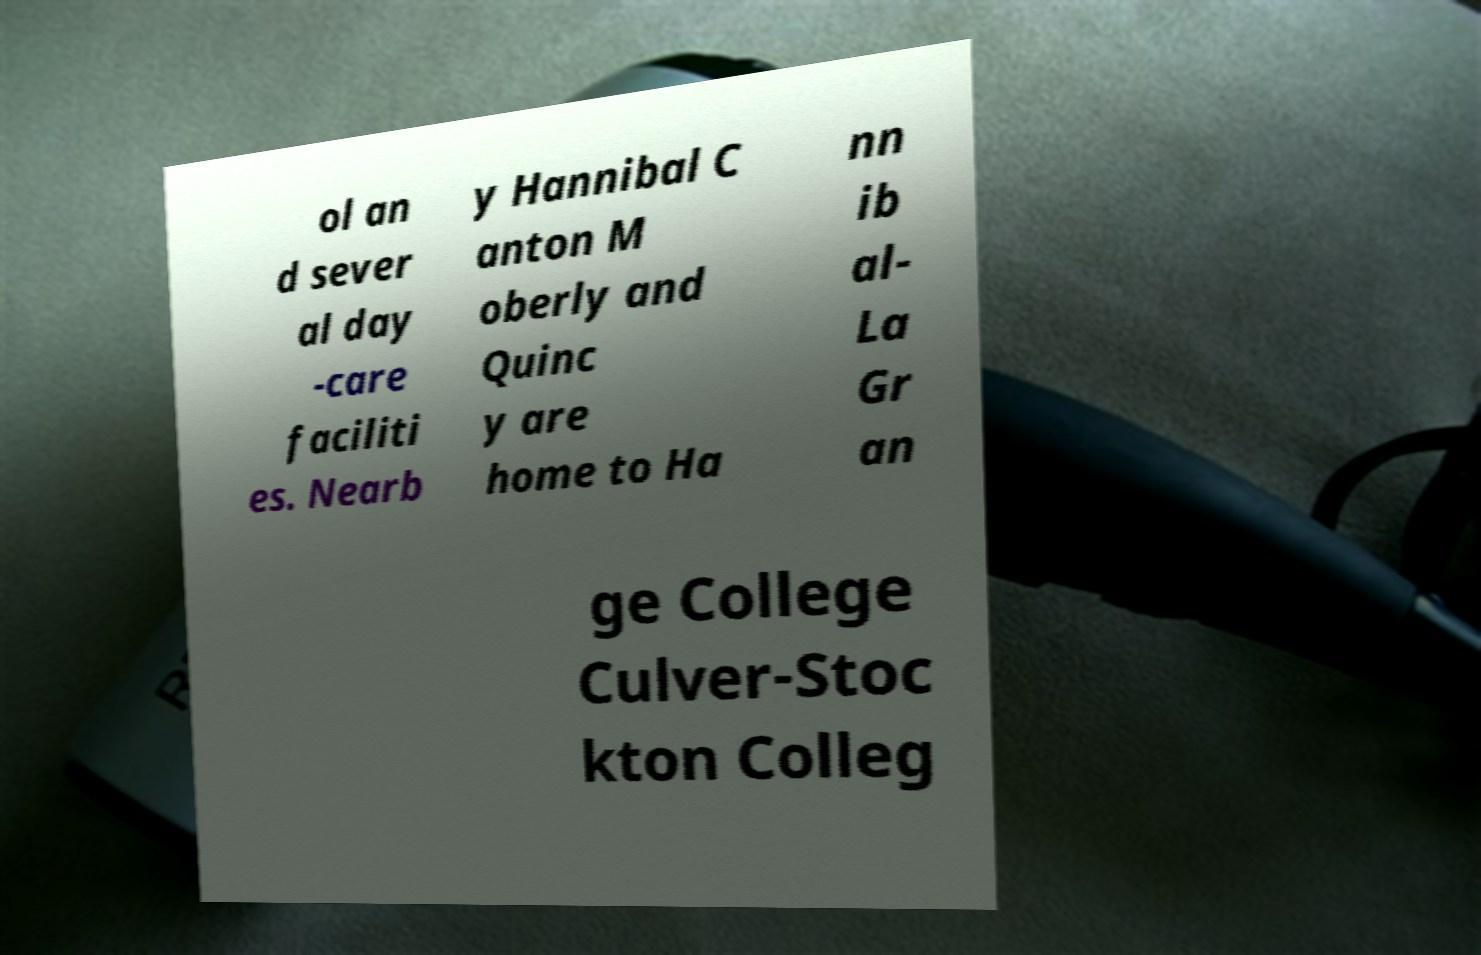Could you extract and type out the text from this image? ol an d sever al day -care faciliti es. Nearb y Hannibal C anton M oberly and Quinc y are home to Ha nn ib al- La Gr an ge College Culver-Stoc kton Colleg 